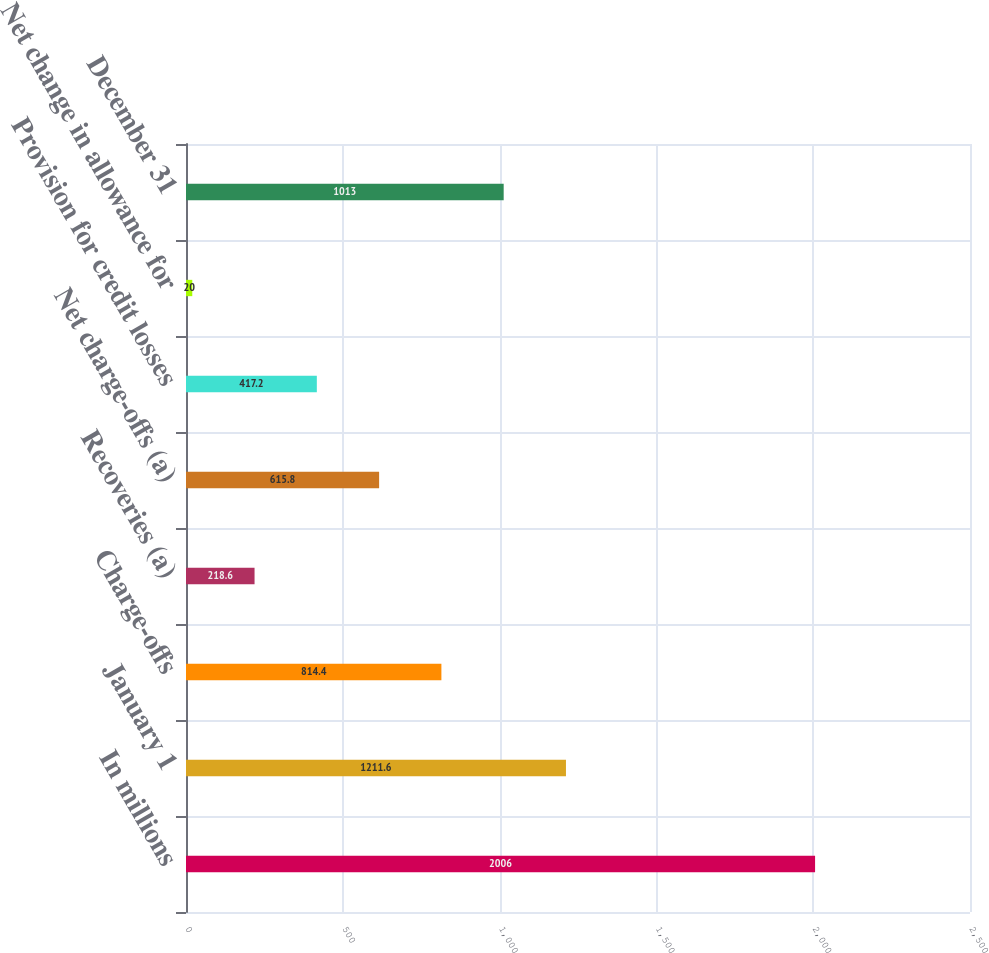Convert chart to OTSL. <chart><loc_0><loc_0><loc_500><loc_500><bar_chart><fcel>In millions<fcel>January 1<fcel>Charge-offs<fcel>Recoveries (a)<fcel>Net charge-offs (a)<fcel>Provision for credit losses<fcel>Net change in allowance for<fcel>December 31<nl><fcel>2006<fcel>1211.6<fcel>814.4<fcel>218.6<fcel>615.8<fcel>417.2<fcel>20<fcel>1013<nl></chart> 